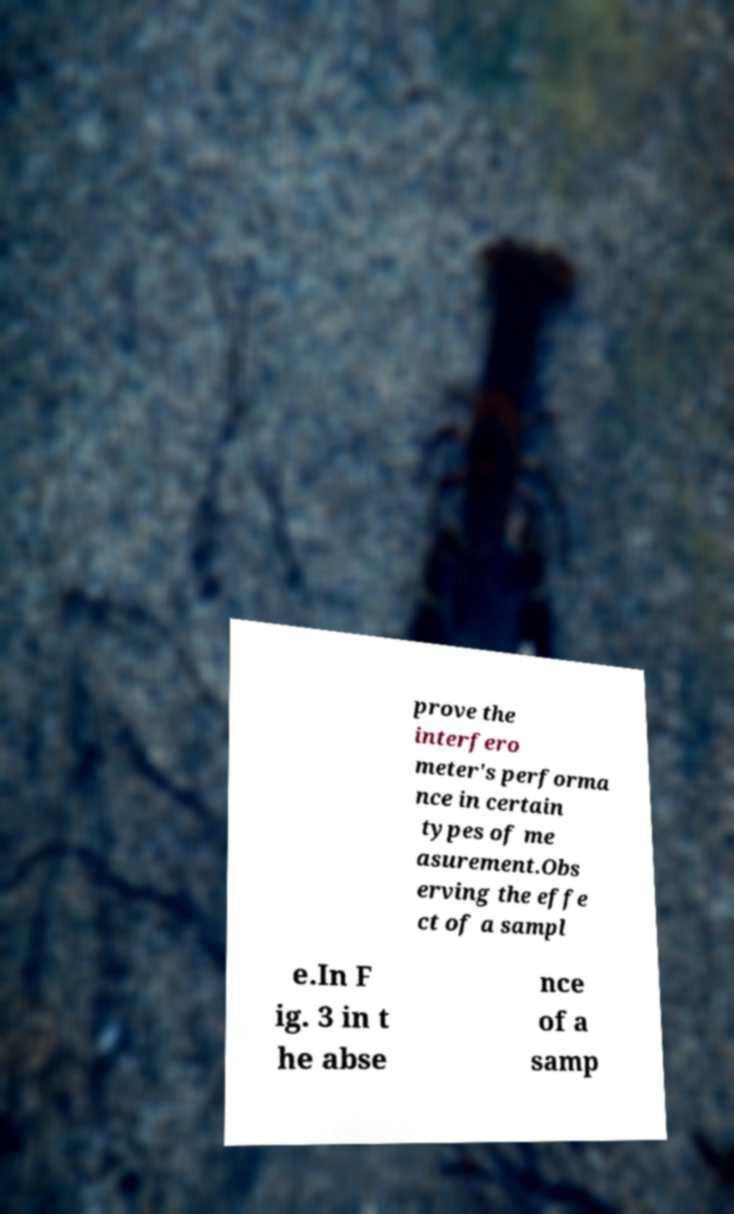I need the written content from this picture converted into text. Can you do that? prove the interfero meter's performa nce in certain types of me asurement.Obs erving the effe ct of a sampl e.In F ig. 3 in t he abse nce of a samp 